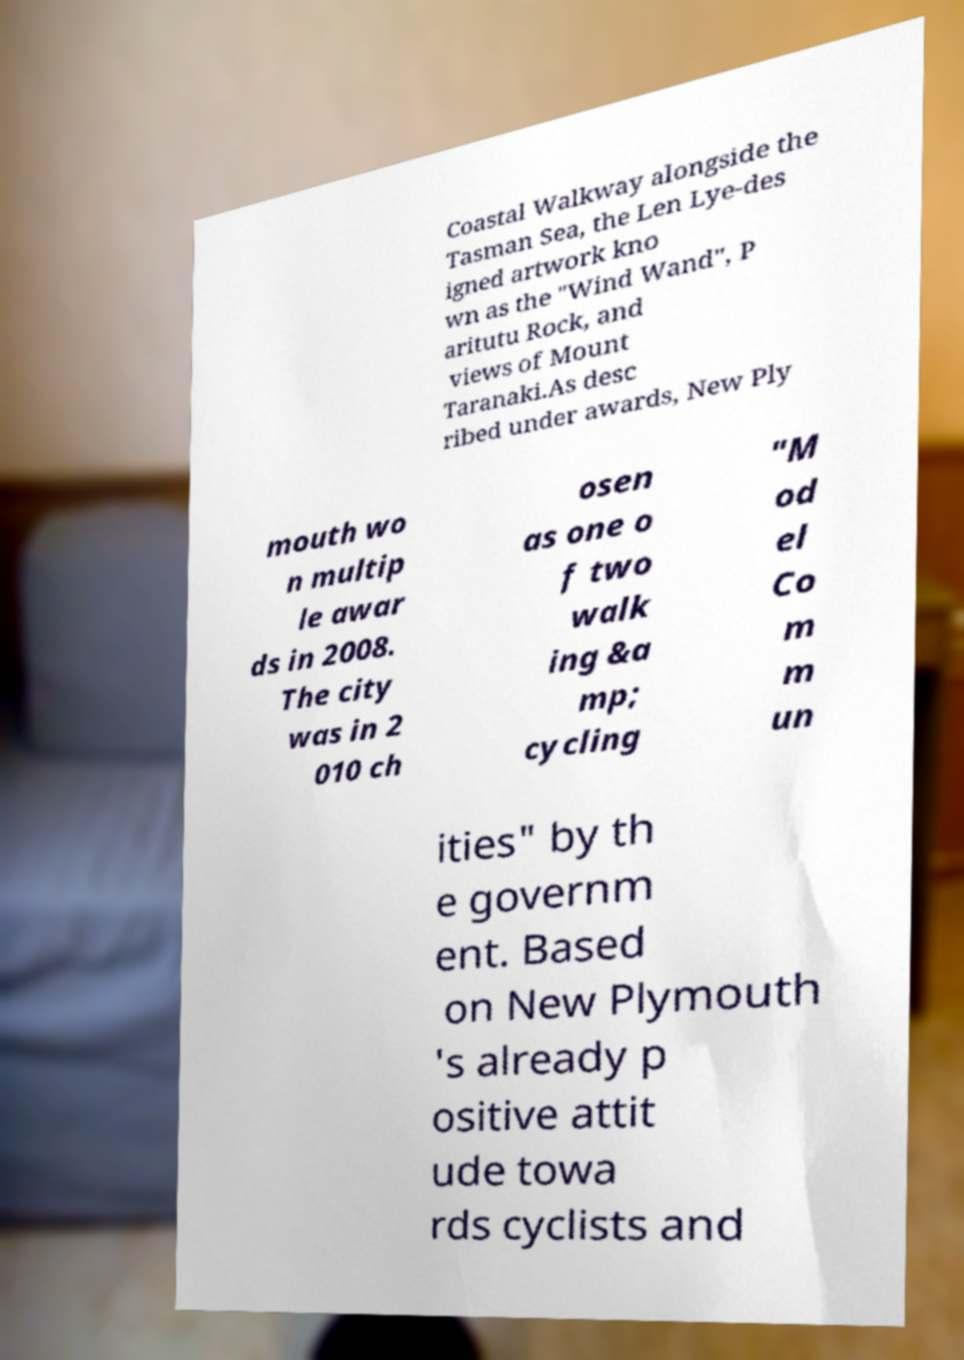What messages or text are displayed in this image? I need them in a readable, typed format. Coastal Walkway alongside the Tasman Sea, the Len Lye-des igned artwork kno wn as the "Wind Wand", P aritutu Rock, and views of Mount Taranaki.As desc ribed under awards, New Ply mouth wo n multip le awar ds in 2008. The city was in 2 010 ch osen as one o f two walk ing &a mp; cycling "M od el Co m m un ities" by th e governm ent. Based on New Plymouth 's already p ositive attit ude towa rds cyclists and 